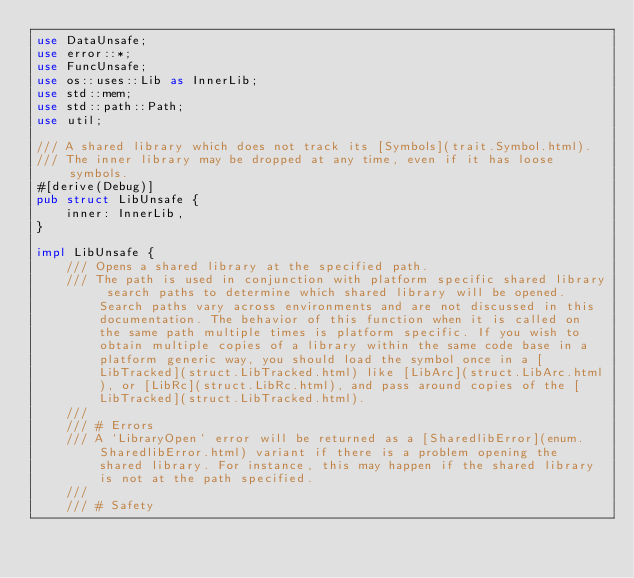<code> <loc_0><loc_0><loc_500><loc_500><_Rust_>use DataUnsafe;
use error::*;
use FuncUnsafe;
use os::uses::Lib as InnerLib;
use std::mem;
use std::path::Path;
use util;

/// A shared library which does not track its [Symbols](trait.Symbol.html).
/// The inner library may be dropped at any time, even if it has loose symbols.
#[derive(Debug)]
pub struct LibUnsafe {
    inner: InnerLib,
}

impl LibUnsafe {
    /// Opens a shared library at the specified path.
    /// The path is used in conjunction with platform specific shared library search paths to determine which shared library will be opened. Search paths vary across environments and are not discussed in this documentation. The behavior of this function when it is called on the same path multiple times is platform specific. If you wish to obtain multiple copies of a library within the same code base in a platform generic way, you should load the symbol once in a [LibTracked](struct.LibTracked.html) like [LibArc](struct.LibArc.html), or [LibRc](struct.LibRc.html), and pass around copies of the [LibTracked](struct.LibTracked.html).
    ///
    /// # Errors
    /// A `LibraryOpen` error will be returned as a [SharedlibError](enum.SharedlibError.html) variant if there is a problem opening the shared library. For instance, this may happen if the shared library is not at the path specified.
    ///
    /// # Safety</code> 